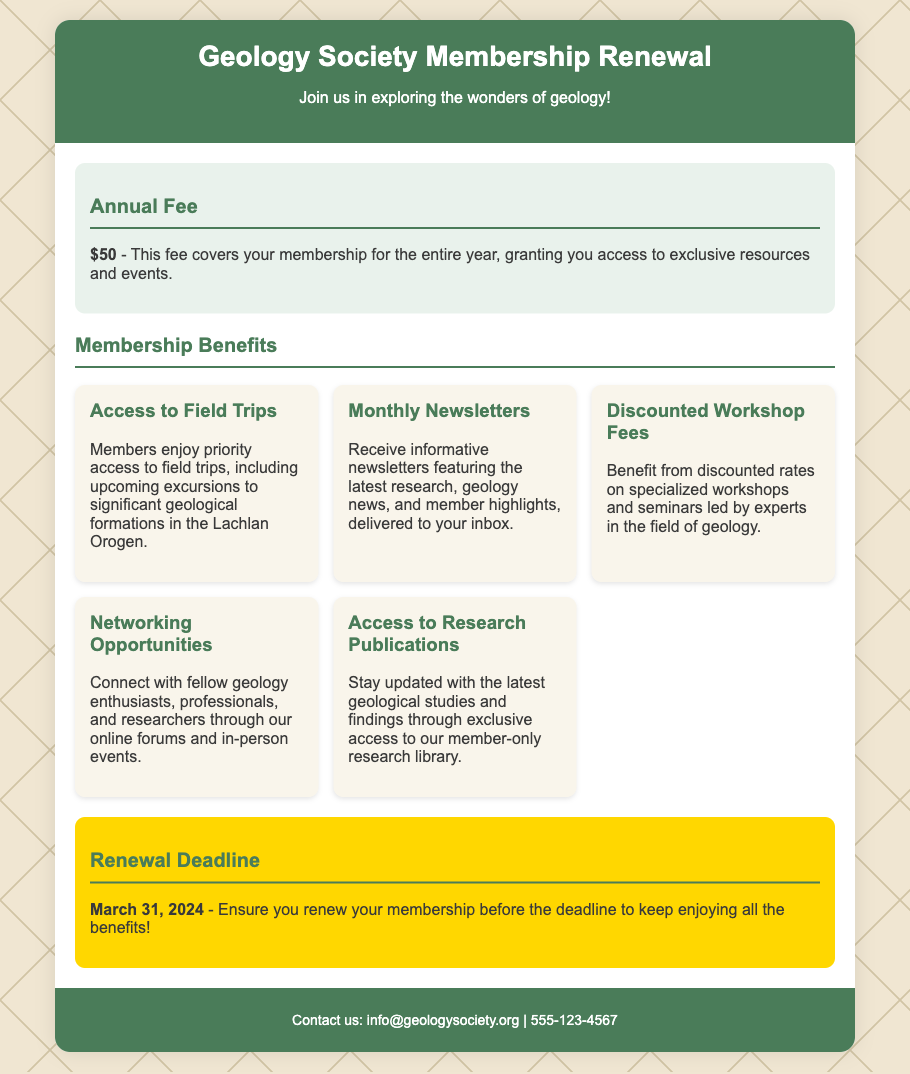What is the annual fee for membership? The annual fee is mentioned directly in the document as $50.
Answer: $50 When is the membership renewal deadline? The document clearly states that the renewal deadline is March 31, 2024.
Answer: March 31, 2024 What benefit provides priority access to field trips? The specific benefit that provides priority access to field trips is listed as "Access to Field Trips."
Answer: Access to Field Trips Which benefit allows members to connect with other geology enthusiasts? The benefit that allows connections with other enthusiasts is "Networking Opportunities."
Answer: Networking Opportunities How many benefits are listed in the document? The document outlines five distinct membership benefits.
Answer: Five What is one of the benefits regarding workshop fees? The document states that members benefit from discounted rates on workshops and seminars.
Answer: Discounted Workshop Fees What type of publications do members get access to? Members have access to research publications through the member-only research library.
Answer: Research Publications What is included in the monthly newsletters? The newsletters feature the latest research, geology news, and member highlights.
Answer: Latest research, geology news, and member highlights What is the primary purpose of this document? The document serves to inform about membership renewal for the Geology Society.
Answer: Membership renewal 